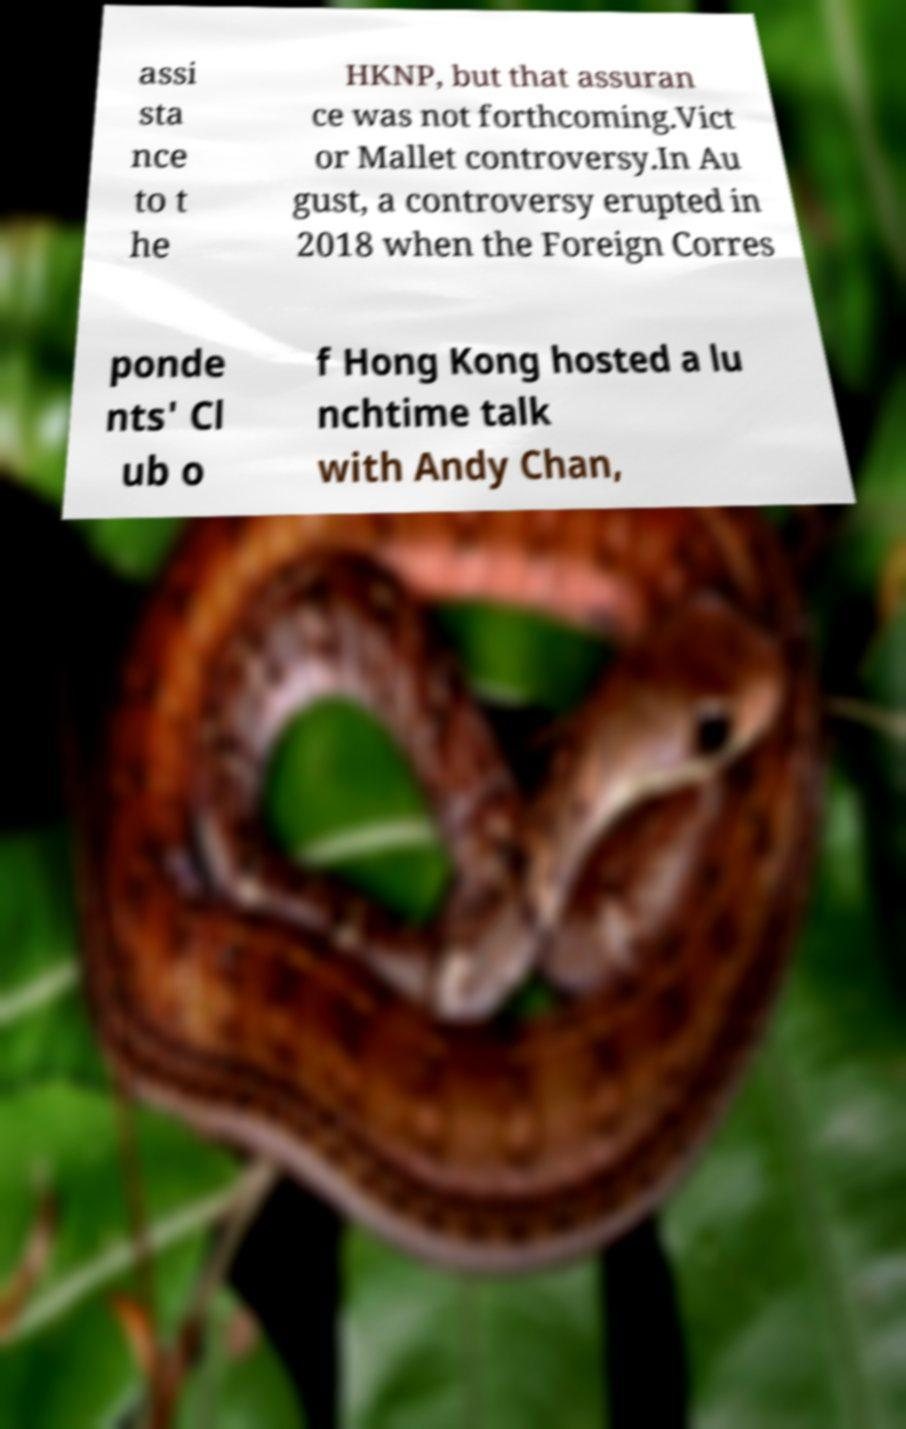Could you assist in decoding the text presented in this image and type it out clearly? assi sta nce to t he HKNP, but that assuran ce was not forthcoming.Vict or Mallet controversy.In Au gust, a controversy erupted in 2018 when the Foreign Corres ponde nts' Cl ub o f Hong Kong hosted a lu nchtime talk with Andy Chan, 